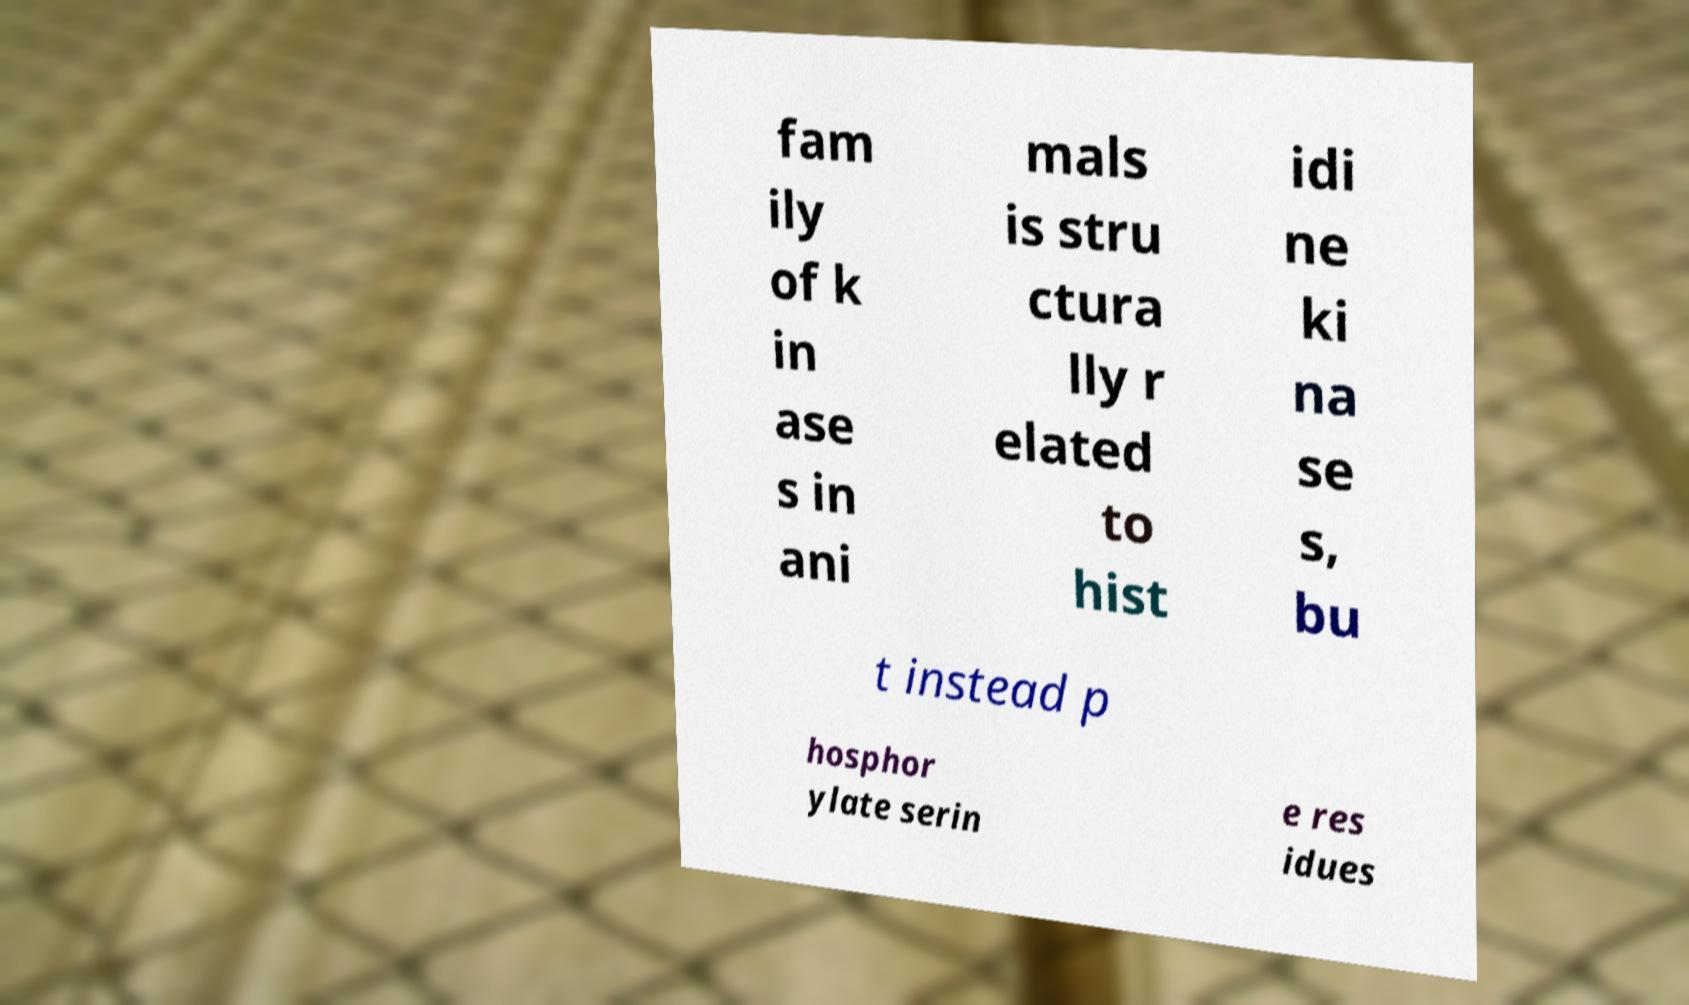Could you extract and type out the text from this image? fam ily of k in ase s in ani mals is stru ctura lly r elated to hist idi ne ki na se s, bu t instead p hosphor ylate serin e res idues 